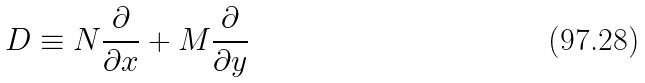Convert formula to latex. <formula><loc_0><loc_0><loc_500><loc_500>D \equiv N { \frac { \partial } { \partial x } } + M { \frac { \partial } { \partial y } }</formula> 